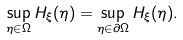Convert formula to latex. <formula><loc_0><loc_0><loc_500><loc_500>\sup _ { \eta \in \Omega } H _ { \xi } ( \eta ) = \sup _ { \eta \in \partial \Omega } H _ { \xi } ( \eta ) .</formula> 